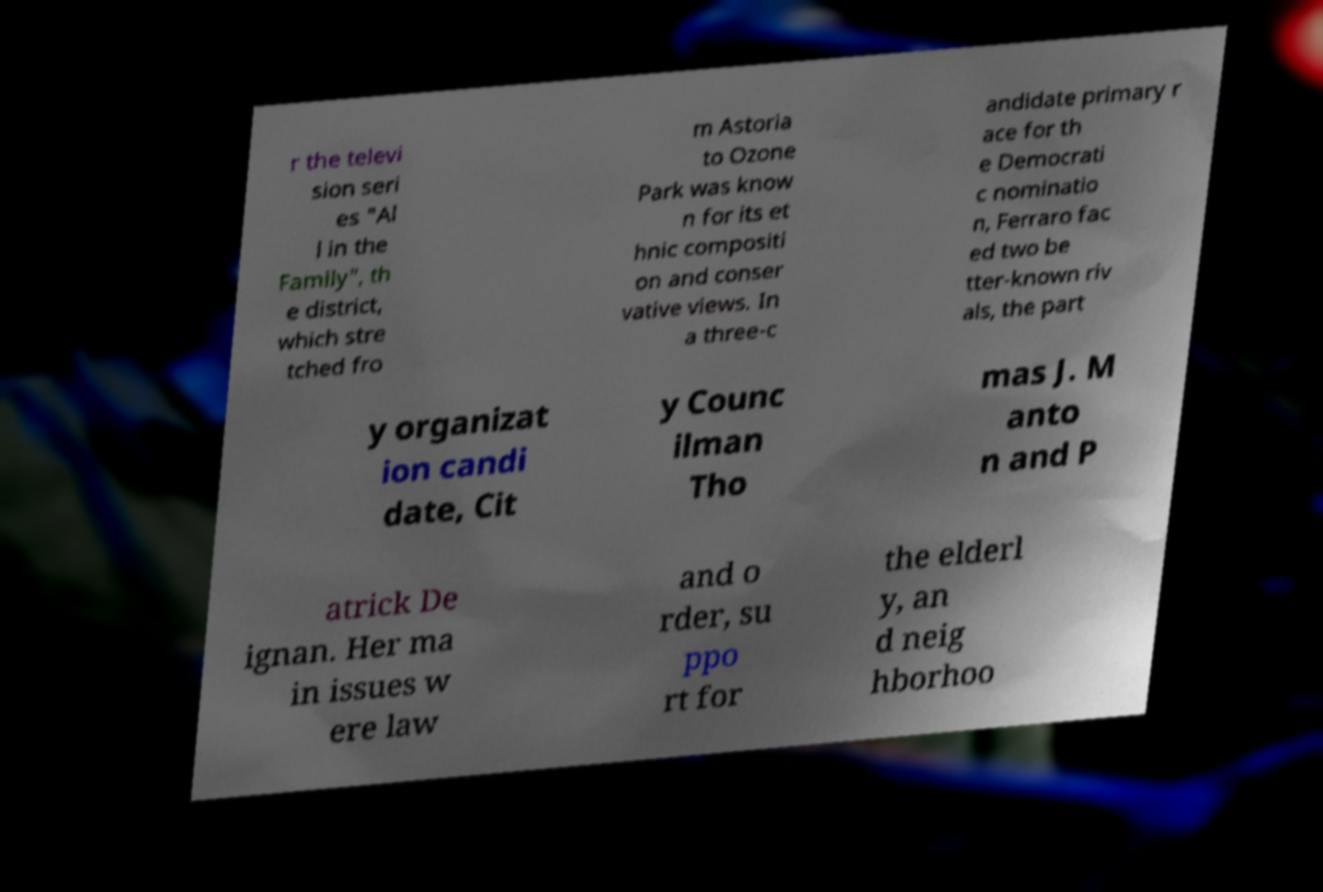I need the written content from this picture converted into text. Can you do that? r the televi sion seri es "Al l in the Family", th e district, which stre tched fro m Astoria to Ozone Park was know n for its et hnic compositi on and conser vative views. In a three-c andidate primary r ace for th e Democrati c nominatio n, Ferraro fac ed two be tter-known riv als, the part y organizat ion candi date, Cit y Counc ilman Tho mas J. M anto n and P atrick De ignan. Her ma in issues w ere law and o rder, su ppo rt for the elderl y, an d neig hborhoo 